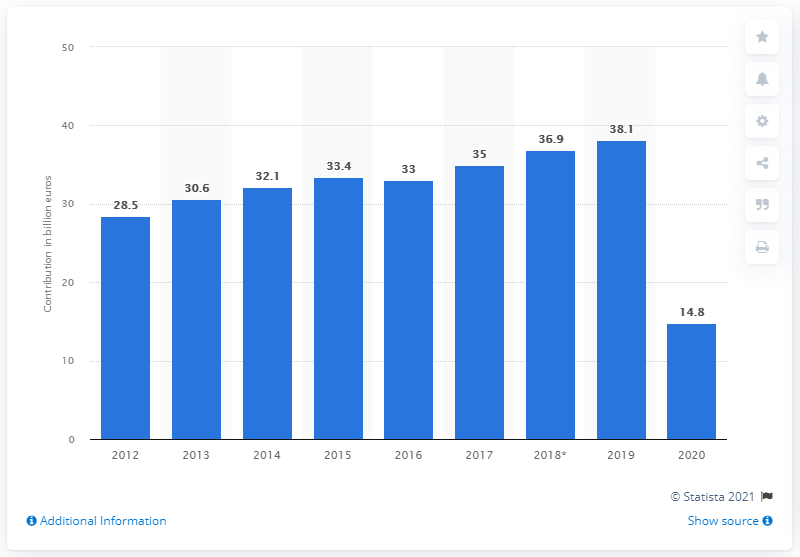Indicate a few pertinent items in this graphic. In 2019, the contribution of travel and tourism to Greece's GDP was 38.1%. In 2020, the total contribution of travel and tourism to Greece's GDP was 14.8. 